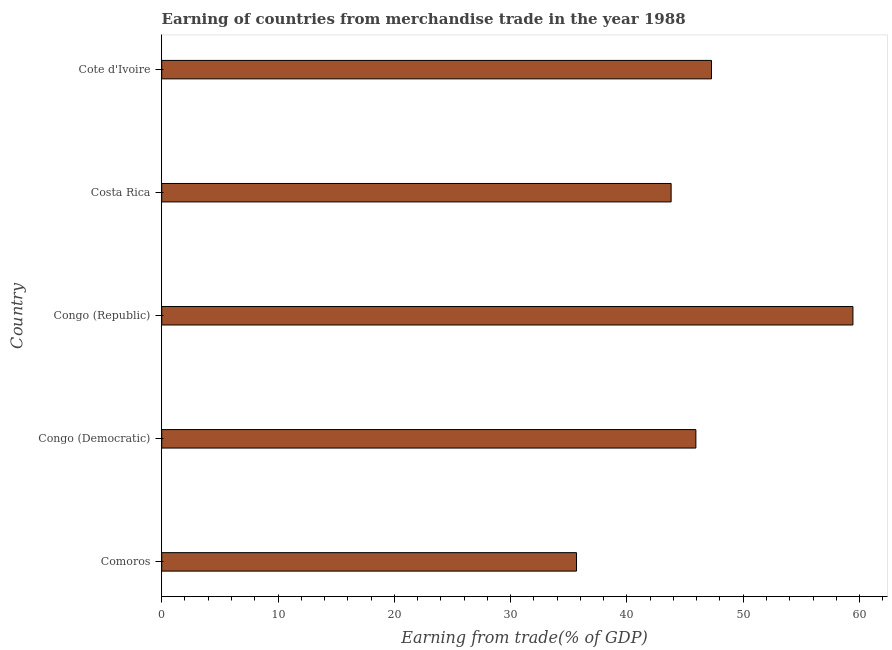Does the graph contain grids?
Your answer should be compact. No. What is the title of the graph?
Provide a short and direct response. Earning of countries from merchandise trade in the year 1988. What is the label or title of the X-axis?
Give a very brief answer. Earning from trade(% of GDP). What is the label or title of the Y-axis?
Make the answer very short. Country. What is the earning from merchandise trade in Cote d'Ivoire?
Ensure brevity in your answer.  47.27. Across all countries, what is the maximum earning from merchandise trade?
Keep it short and to the point. 59.43. Across all countries, what is the minimum earning from merchandise trade?
Your response must be concise. 35.67. In which country was the earning from merchandise trade maximum?
Make the answer very short. Congo (Republic). In which country was the earning from merchandise trade minimum?
Keep it short and to the point. Comoros. What is the sum of the earning from merchandise trade?
Offer a terse response. 232.11. What is the difference between the earning from merchandise trade in Comoros and Congo (Republic)?
Keep it short and to the point. -23.77. What is the average earning from merchandise trade per country?
Make the answer very short. 46.42. What is the median earning from merchandise trade?
Your response must be concise. 45.93. In how many countries, is the earning from merchandise trade greater than 30 %?
Provide a short and direct response. 5. What is the ratio of the earning from merchandise trade in Comoros to that in Costa Rica?
Your answer should be very brief. 0.81. Is the earning from merchandise trade in Congo (Republic) less than that in Cote d'Ivoire?
Your answer should be compact. No. What is the difference between the highest and the second highest earning from merchandise trade?
Your response must be concise. 12.16. Is the sum of the earning from merchandise trade in Comoros and Costa Rica greater than the maximum earning from merchandise trade across all countries?
Ensure brevity in your answer.  Yes. What is the difference between the highest and the lowest earning from merchandise trade?
Provide a succinct answer. 23.77. In how many countries, is the earning from merchandise trade greater than the average earning from merchandise trade taken over all countries?
Your answer should be very brief. 2. How many bars are there?
Your answer should be compact. 5. What is the difference between two consecutive major ticks on the X-axis?
Your answer should be very brief. 10. What is the Earning from trade(% of GDP) of Comoros?
Provide a succinct answer. 35.67. What is the Earning from trade(% of GDP) in Congo (Democratic)?
Make the answer very short. 45.93. What is the Earning from trade(% of GDP) of Congo (Republic)?
Keep it short and to the point. 59.43. What is the Earning from trade(% of GDP) in Costa Rica?
Make the answer very short. 43.8. What is the Earning from trade(% of GDP) of Cote d'Ivoire?
Your answer should be very brief. 47.27. What is the difference between the Earning from trade(% of GDP) in Comoros and Congo (Democratic)?
Your answer should be very brief. -10.26. What is the difference between the Earning from trade(% of GDP) in Comoros and Congo (Republic)?
Your response must be concise. -23.77. What is the difference between the Earning from trade(% of GDP) in Comoros and Costa Rica?
Your answer should be compact. -8.13. What is the difference between the Earning from trade(% of GDP) in Comoros and Cote d'Ivoire?
Your answer should be compact. -11.61. What is the difference between the Earning from trade(% of GDP) in Congo (Democratic) and Congo (Republic)?
Offer a very short reply. -13.5. What is the difference between the Earning from trade(% of GDP) in Congo (Democratic) and Costa Rica?
Provide a short and direct response. 2.13. What is the difference between the Earning from trade(% of GDP) in Congo (Democratic) and Cote d'Ivoire?
Offer a terse response. -1.34. What is the difference between the Earning from trade(% of GDP) in Congo (Republic) and Costa Rica?
Offer a very short reply. 15.63. What is the difference between the Earning from trade(% of GDP) in Congo (Republic) and Cote d'Ivoire?
Give a very brief answer. 12.16. What is the difference between the Earning from trade(% of GDP) in Costa Rica and Cote d'Ivoire?
Make the answer very short. -3.47. What is the ratio of the Earning from trade(% of GDP) in Comoros to that in Congo (Democratic)?
Offer a terse response. 0.78. What is the ratio of the Earning from trade(% of GDP) in Comoros to that in Congo (Republic)?
Give a very brief answer. 0.6. What is the ratio of the Earning from trade(% of GDP) in Comoros to that in Costa Rica?
Offer a terse response. 0.81. What is the ratio of the Earning from trade(% of GDP) in Comoros to that in Cote d'Ivoire?
Your answer should be very brief. 0.75. What is the ratio of the Earning from trade(% of GDP) in Congo (Democratic) to that in Congo (Republic)?
Offer a very short reply. 0.77. What is the ratio of the Earning from trade(% of GDP) in Congo (Democratic) to that in Costa Rica?
Give a very brief answer. 1.05. What is the ratio of the Earning from trade(% of GDP) in Congo (Democratic) to that in Cote d'Ivoire?
Your answer should be compact. 0.97. What is the ratio of the Earning from trade(% of GDP) in Congo (Republic) to that in Costa Rica?
Provide a succinct answer. 1.36. What is the ratio of the Earning from trade(% of GDP) in Congo (Republic) to that in Cote d'Ivoire?
Your answer should be very brief. 1.26. What is the ratio of the Earning from trade(% of GDP) in Costa Rica to that in Cote d'Ivoire?
Give a very brief answer. 0.93. 